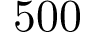Convert formula to latex. <formula><loc_0><loc_0><loc_500><loc_500>5 0 0</formula> 